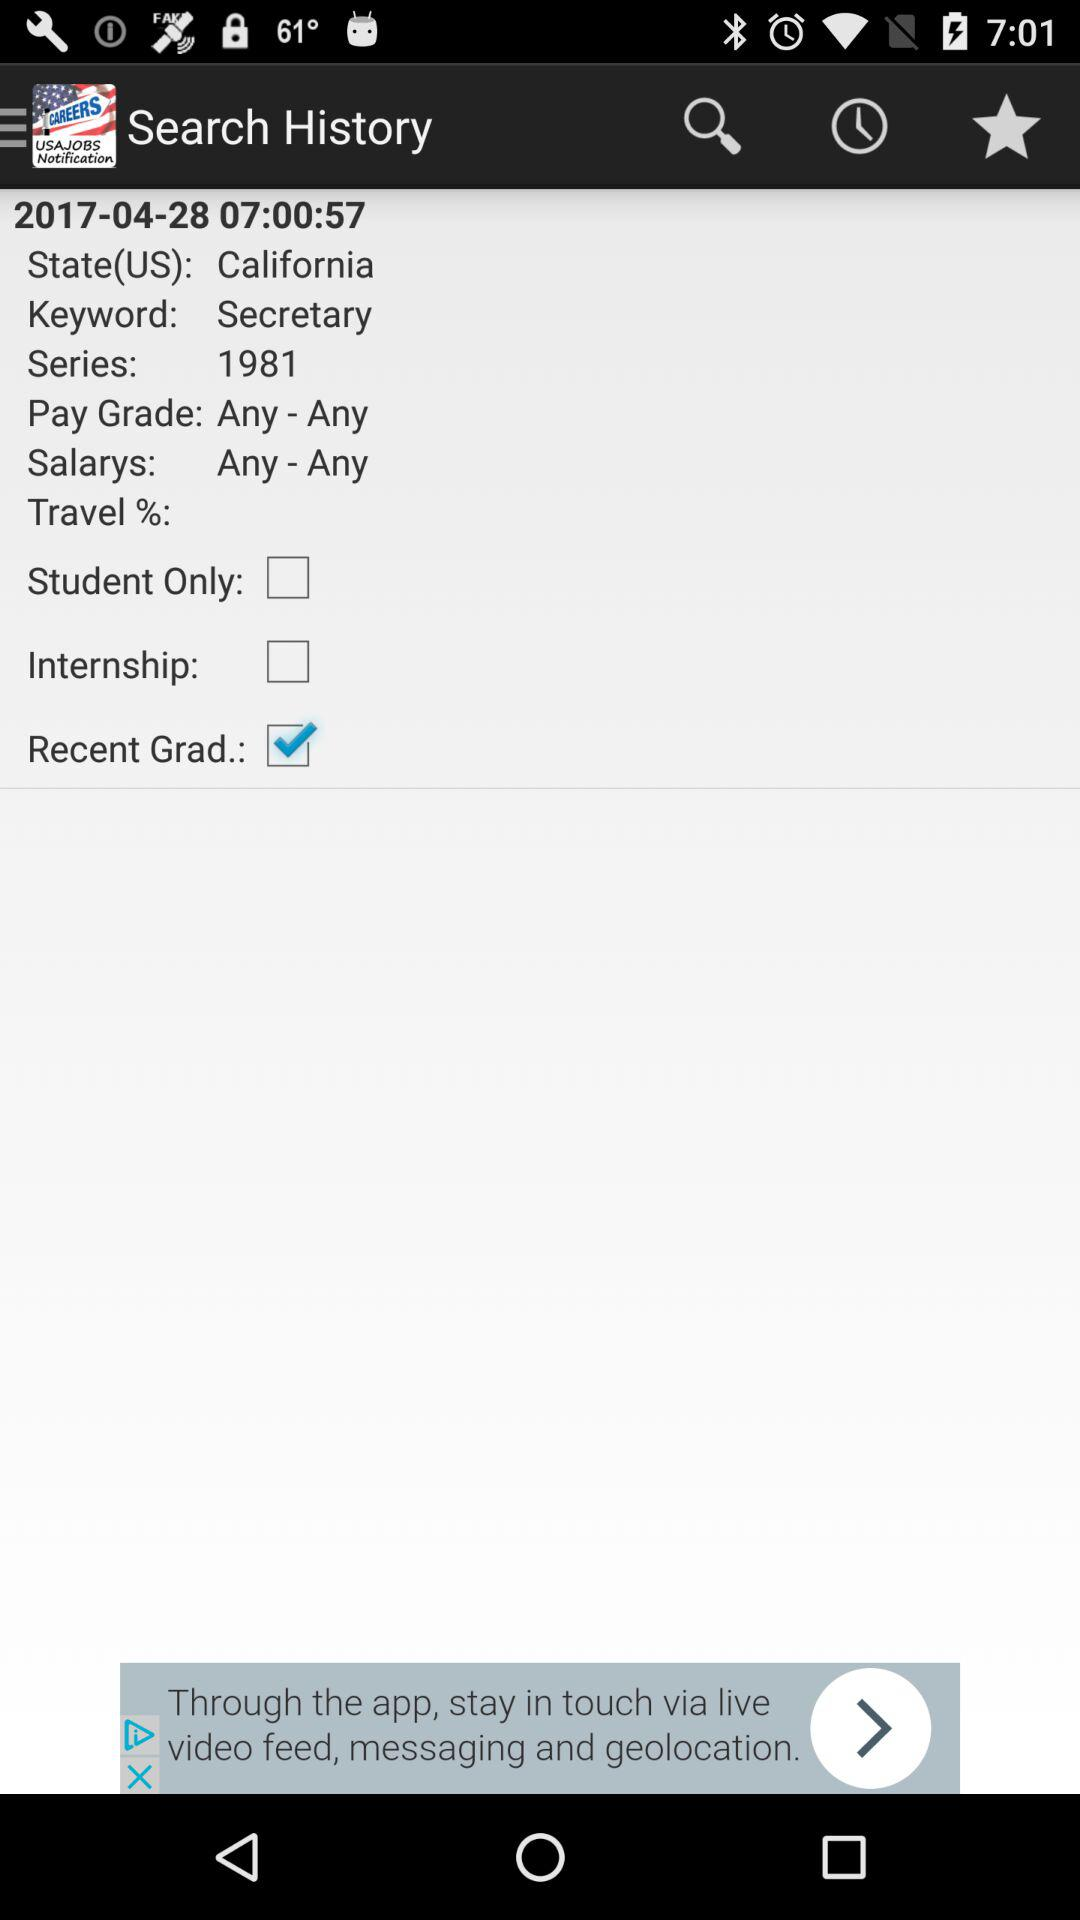What is the given "State"? The given "State" is California. 